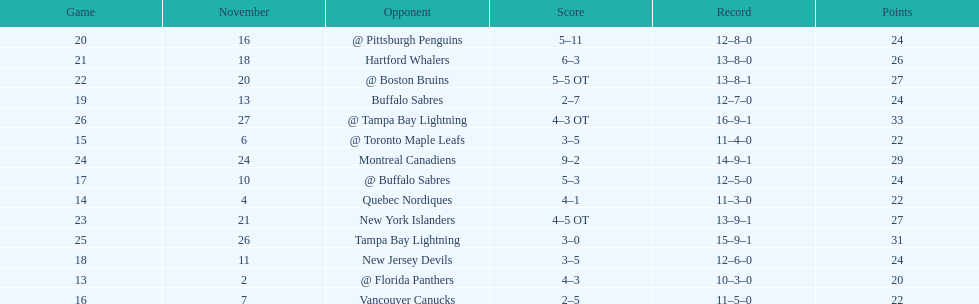The 1993-1994 flyers missed the playoffs again. how many consecutive seasons up until 93-94 did the flyers miss the playoffs? 5. 